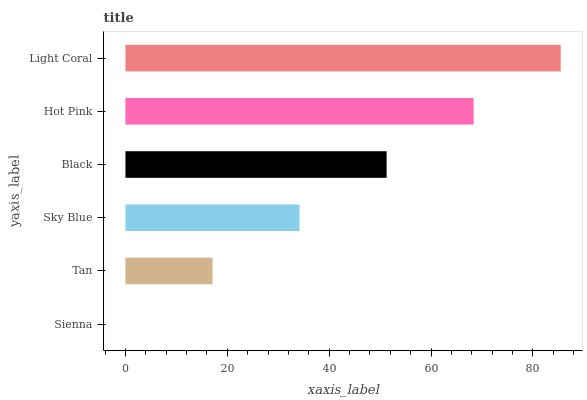Is Sienna the minimum?
Answer yes or no. Yes. Is Light Coral the maximum?
Answer yes or no. Yes. Is Tan the minimum?
Answer yes or no. No. Is Tan the maximum?
Answer yes or no. No. Is Tan greater than Sienna?
Answer yes or no. Yes. Is Sienna less than Tan?
Answer yes or no. Yes. Is Sienna greater than Tan?
Answer yes or no. No. Is Tan less than Sienna?
Answer yes or no. No. Is Black the high median?
Answer yes or no. Yes. Is Sky Blue the low median?
Answer yes or no. Yes. Is Tan the high median?
Answer yes or no. No. Is Light Coral the low median?
Answer yes or no. No. 